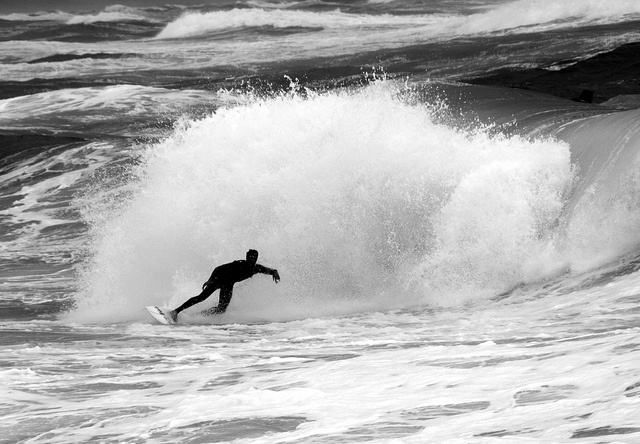Describe the objects in this image and their specific colors. I can see people in black, darkgray, gray, and lightgray tones and surfboard in black, darkgray, lightgray, and gray tones in this image. 